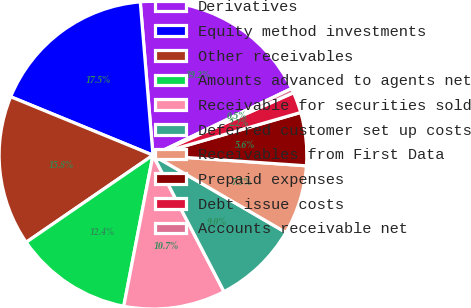<chart> <loc_0><loc_0><loc_500><loc_500><pie_chart><fcel>Derivatives<fcel>Equity method investments<fcel>Other receivables<fcel>Amounts advanced to agents net<fcel>Receivable for securities sold<fcel>Deferred customer set up costs<fcel>Receivables from First Data<fcel>Prepaid expenses<fcel>Debt issue costs<fcel>Accounts receivable net<nl><fcel>19.18%<fcel>17.48%<fcel>15.78%<fcel>12.38%<fcel>10.68%<fcel>8.98%<fcel>7.28%<fcel>5.58%<fcel>2.18%<fcel>0.48%<nl></chart> 